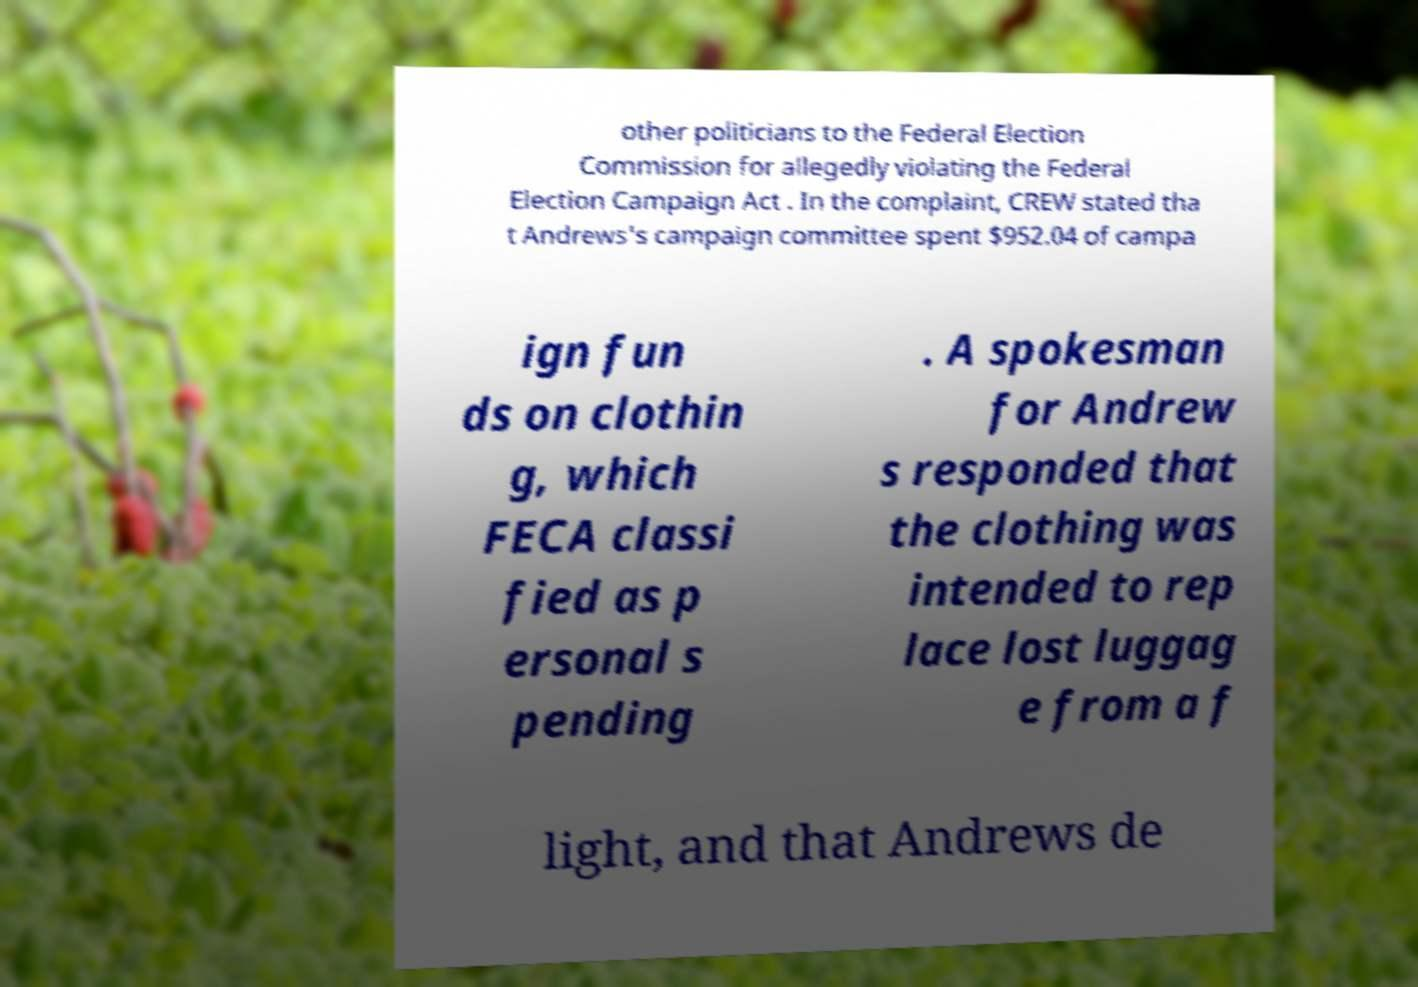Please read and relay the text visible in this image. What does it say? other politicians to the Federal Election Commission for allegedly violating the Federal Election Campaign Act . In the complaint, CREW stated tha t Andrews's campaign committee spent $952.04 of campa ign fun ds on clothin g, which FECA classi fied as p ersonal s pending . A spokesman for Andrew s responded that the clothing was intended to rep lace lost luggag e from a f light, and that Andrews de 